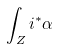Convert formula to latex. <formula><loc_0><loc_0><loc_500><loc_500>\int _ { Z } i ^ { * } \alpha</formula> 